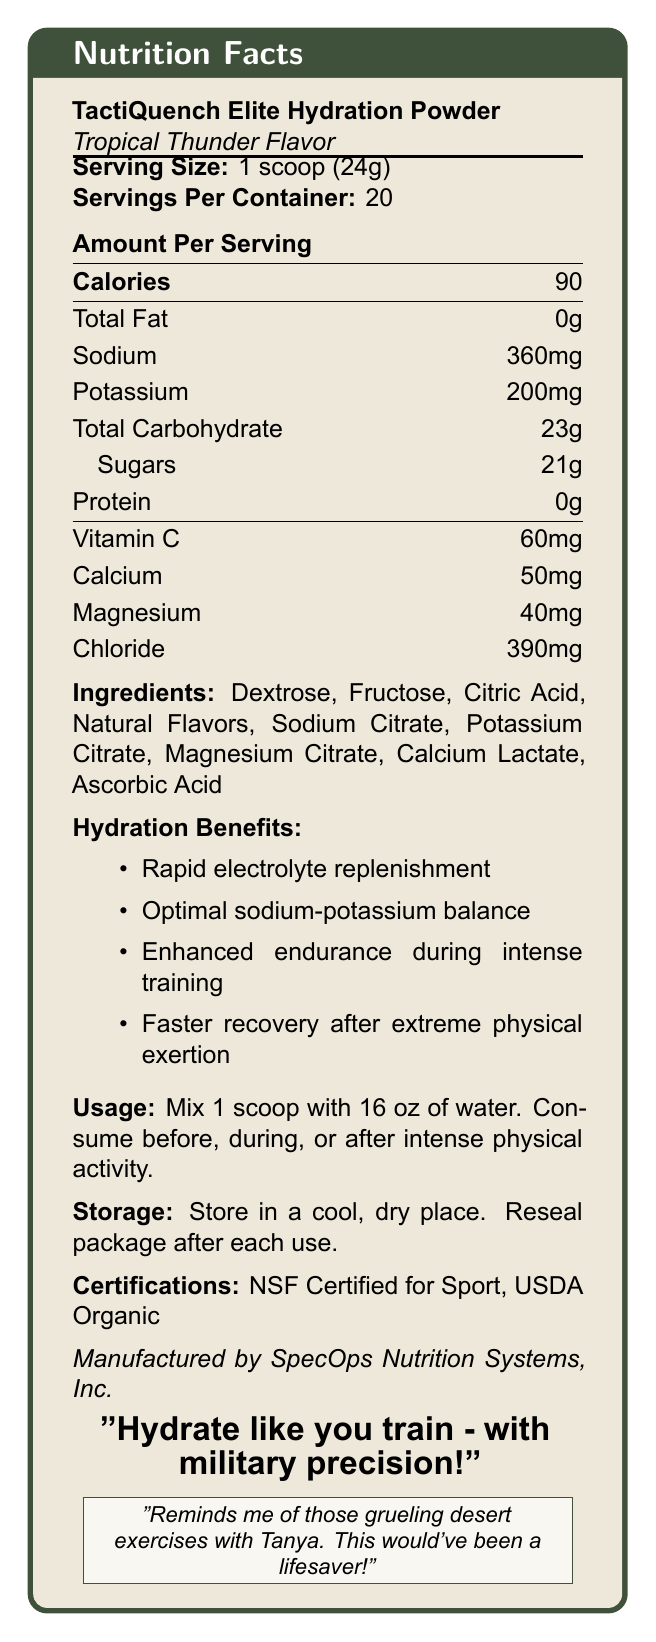what is the serving size? The serving size is mentioned directly under the product name "TactiQuench Elite Hydration Powder" and is listed as "1 scoop (24g)."
Answer: 1 scoop (24g) how many servings are in one container? The label states "Servings Per Container: 20" beneath the serving size details.
Answer: 20 how many calories does each serving contain? The label shows "Calories: 90" under the heading "Amount Per Serving."
Answer: 90 what is the slogan of the product? The slogan is placed at the bottom of the document, highlighted and centered.
Answer: "Hydrate like you train - with military precision!" name one benefit of consuming this hydration powder. One of the listed hydration benefits is "Rapid electrolyte replenishment."
Answer: Rapid electrolyte replenishment what is the total carbohydrate content per serving? Under the Amount Per Serving section, it lists "Total Carbohydrate: 23g."
Answer: 23g which ingredient is mentioned first? A. Fructose B. Dextrose C. Potassium Citrate D. Calcium Lactate The first ingredient listed is "Dextrose."
Answer: B how much sodium does one serving contain? The document states "Sodium: 360mg" under the Amount Per Serving section.
Answer: 360mg how should the product be consumed? A. With 8 oz of water B. With 12 oz of water C. With 16 oz of water D. With 24 oz of water The usage instructions state to "Mix 1 scoop with 16 oz of water."
Answer: C true or false: This product contains protein. The Amount Per Serving section lists "Protein: 0g," indicating there is no protein content in the product.
Answer: False what are the necessary storage conditions? The storage instructions state to "Store in a cool, dry place. Reseal package after each use."
Answer: Store in a cool, dry place. Reseal package after each use. how much Vitamin C does a serving provide? The Amount Per Serving section lists "Vitamin C: 60mg."
Answer: 60mg what certifications does this product have? The certifications mentioned are "NSF Certified for Sport, USDA Organic."
Answer: NSF Certified for Sport, USDA Organic what is the flavor of the TactiQuench Elite Hydration Powder? The label mentions "Tropical Thunder Flavor" below the product name.
Answer: Tropical Thunder which company manufactures this product? The label states that it is "Manufactured by SpecOps Nutrition Systems, Inc." near the bottom.
Answer: SpecOps Nutrition Systems, Inc. what is the main idea of the document? The document covers the nutrition facts, ingredients, usage instructions, storage conditions, certifications, and hydration benefits of the product, which is specifically formulated for intense training.
Answer: The document provides detailed nutrition facts and benefits of the TactiQuench Elite Hydration Powder, emphasizing its role in rapid hydration and electrolyte replenishment during intense training exercises. how did the product’s description evoke a sense of nostalgia? The bottom portion of the document includes a nostalgic statement mentioning desert exercises with Tanya, emphasizing the product's potential benefits during such grueling conditions.
Answer: The tagline mentions, "Reminds me of those grueling desert exercises with Tanya. This would've been a lifesaver!" what is the main source of electrolytes in this product? The document lists the electrolytes present (sodium, potassium, magnesium, and chloride) but does not specify which ingredient is the main source of electrolytes.
Answer: Not enough information 